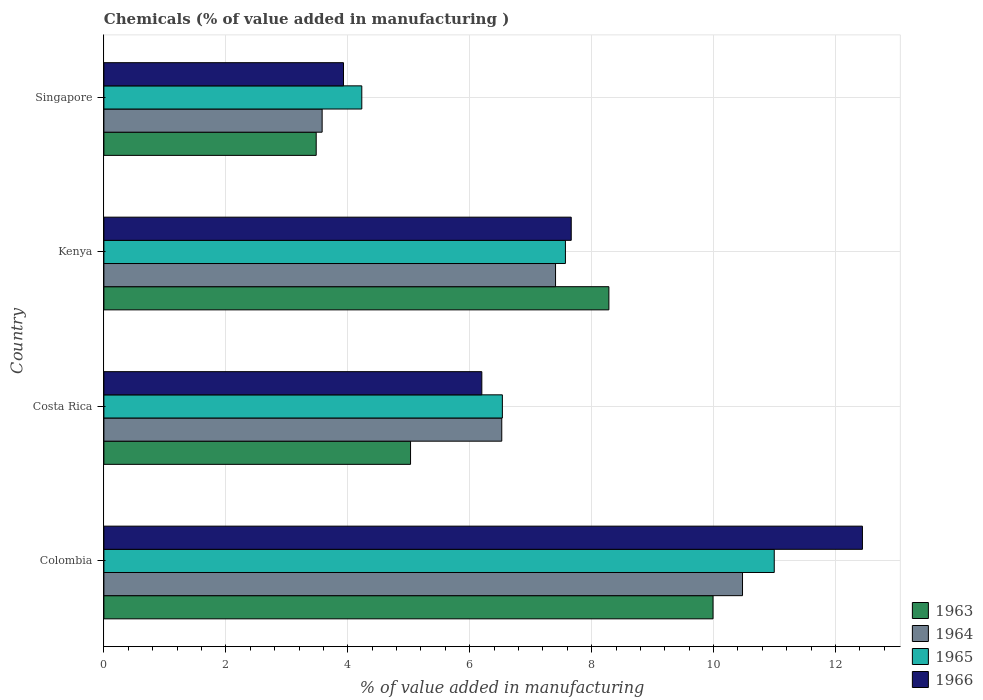Are the number of bars per tick equal to the number of legend labels?
Ensure brevity in your answer.  Yes. What is the label of the 1st group of bars from the top?
Keep it short and to the point. Singapore. In how many cases, is the number of bars for a given country not equal to the number of legend labels?
Keep it short and to the point. 0. What is the value added in manufacturing chemicals in 1963 in Costa Rica?
Make the answer very short. 5.03. Across all countries, what is the maximum value added in manufacturing chemicals in 1964?
Offer a very short reply. 10.47. Across all countries, what is the minimum value added in manufacturing chemicals in 1964?
Give a very brief answer. 3.58. In which country was the value added in manufacturing chemicals in 1964 minimum?
Make the answer very short. Singapore. What is the total value added in manufacturing chemicals in 1966 in the graph?
Give a very brief answer. 30.23. What is the difference between the value added in manufacturing chemicals in 1964 in Colombia and that in Costa Rica?
Give a very brief answer. 3.95. What is the difference between the value added in manufacturing chemicals in 1964 in Costa Rica and the value added in manufacturing chemicals in 1965 in Singapore?
Provide a succinct answer. 2.3. What is the average value added in manufacturing chemicals in 1963 per country?
Offer a very short reply. 6.7. What is the difference between the value added in manufacturing chemicals in 1965 and value added in manufacturing chemicals in 1963 in Colombia?
Keep it short and to the point. 1. What is the ratio of the value added in manufacturing chemicals in 1963 in Colombia to that in Costa Rica?
Your response must be concise. 1.99. Is the difference between the value added in manufacturing chemicals in 1965 in Kenya and Singapore greater than the difference between the value added in manufacturing chemicals in 1963 in Kenya and Singapore?
Keep it short and to the point. No. What is the difference between the highest and the second highest value added in manufacturing chemicals in 1965?
Offer a very short reply. 3.43. What is the difference between the highest and the lowest value added in manufacturing chemicals in 1963?
Ensure brevity in your answer.  6.51. In how many countries, is the value added in manufacturing chemicals in 1964 greater than the average value added in manufacturing chemicals in 1964 taken over all countries?
Your answer should be compact. 2. Is it the case that in every country, the sum of the value added in manufacturing chemicals in 1963 and value added in manufacturing chemicals in 1964 is greater than the sum of value added in manufacturing chemicals in 1965 and value added in manufacturing chemicals in 1966?
Provide a succinct answer. No. What does the 2nd bar from the top in Colombia represents?
Offer a very short reply. 1965. What does the 4th bar from the bottom in Kenya represents?
Your answer should be compact. 1966. Is it the case that in every country, the sum of the value added in manufacturing chemicals in 1965 and value added in manufacturing chemicals in 1964 is greater than the value added in manufacturing chemicals in 1963?
Keep it short and to the point. Yes. How many bars are there?
Provide a succinct answer. 16. Are all the bars in the graph horizontal?
Provide a succinct answer. Yes. How many countries are there in the graph?
Provide a succinct answer. 4. Are the values on the major ticks of X-axis written in scientific E-notation?
Offer a very short reply. No. Does the graph contain grids?
Your answer should be compact. Yes. How many legend labels are there?
Your answer should be very brief. 4. What is the title of the graph?
Make the answer very short. Chemicals (% of value added in manufacturing ). What is the label or title of the X-axis?
Keep it short and to the point. % of value added in manufacturing. What is the % of value added in manufacturing in 1963 in Colombia?
Offer a terse response. 9.99. What is the % of value added in manufacturing in 1964 in Colombia?
Ensure brevity in your answer.  10.47. What is the % of value added in manufacturing in 1965 in Colombia?
Provide a succinct answer. 10.99. What is the % of value added in manufacturing of 1966 in Colombia?
Your response must be concise. 12.44. What is the % of value added in manufacturing of 1963 in Costa Rica?
Your response must be concise. 5.03. What is the % of value added in manufacturing of 1964 in Costa Rica?
Keep it short and to the point. 6.53. What is the % of value added in manufacturing of 1965 in Costa Rica?
Ensure brevity in your answer.  6.54. What is the % of value added in manufacturing in 1966 in Costa Rica?
Ensure brevity in your answer.  6.2. What is the % of value added in manufacturing in 1963 in Kenya?
Offer a terse response. 8.28. What is the % of value added in manufacturing in 1964 in Kenya?
Offer a terse response. 7.41. What is the % of value added in manufacturing of 1965 in Kenya?
Offer a very short reply. 7.57. What is the % of value added in manufacturing in 1966 in Kenya?
Offer a very short reply. 7.67. What is the % of value added in manufacturing of 1963 in Singapore?
Your response must be concise. 3.48. What is the % of value added in manufacturing of 1964 in Singapore?
Offer a terse response. 3.58. What is the % of value added in manufacturing of 1965 in Singapore?
Make the answer very short. 4.23. What is the % of value added in manufacturing in 1966 in Singapore?
Provide a succinct answer. 3.93. Across all countries, what is the maximum % of value added in manufacturing in 1963?
Provide a succinct answer. 9.99. Across all countries, what is the maximum % of value added in manufacturing in 1964?
Give a very brief answer. 10.47. Across all countries, what is the maximum % of value added in manufacturing in 1965?
Give a very brief answer. 10.99. Across all countries, what is the maximum % of value added in manufacturing in 1966?
Keep it short and to the point. 12.44. Across all countries, what is the minimum % of value added in manufacturing in 1963?
Offer a very short reply. 3.48. Across all countries, what is the minimum % of value added in manufacturing in 1964?
Provide a succinct answer. 3.58. Across all countries, what is the minimum % of value added in manufacturing of 1965?
Provide a succinct answer. 4.23. Across all countries, what is the minimum % of value added in manufacturing of 1966?
Your answer should be very brief. 3.93. What is the total % of value added in manufacturing of 1963 in the graph?
Make the answer very short. 26.79. What is the total % of value added in manufacturing in 1964 in the graph?
Your answer should be very brief. 27.99. What is the total % of value added in manufacturing in 1965 in the graph?
Offer a terse response. 29.33. What is the total % of value added in manufacturing of 1966 in the graph?
Ensure brevity in your answer.  30.23. What is the difference between the % of value added in manufacturing in 1963 in Colombia and that in Costa Rica?
Offer a terse response. 4.96. What is the difference between the % of value added in manufacturing in 1964 in Colombia and that in Costa Rica?
Your answer should be very brief. 3.95. What is the difference between the % of value added in manufacturing in 1965 in Colombia and that in Costa Rica?
Keep it short and to the point. 4.46. What is the difference between the % of value added in manufacturing in 1966 in Colombia and that in Costa Rica?
Keep it short and to the point. 6.24. What is the difference between the % of value added in manufacturing in 1963 in Colombia and that in Kenya?
Your answer should be very brief. 1.71. What is the difference between the % of value added in manufacturing of 1964 in Colombia and that in Kenya?
Keep it short and to the point. 3.07. What is the difference between the % of value added in manufacturing in 1965 in Colombia and that in Kenya?
Offer a very short reply. 3.43. What is the difference between the % of value added in manufacturing in 1966 in Colombia and that in Kenya?
Offer a terse response. 4.78. What is the difference between the % of value added in manufacturing in 1963 in Colombia and that in Singapore?
Your answer should be very brief. 6.51. What is the difference between the % of value added in manufacturing of 1964 in Colombia and that in Singapore?
Provide a short and direct response. 6.89. What is the difference between the % of value added in manufacturing of 1965 in Colombia and that in Singapore?
Provide a succinct answer. 6.76. What is the difference between the % of value added in manufacturing of 1966 in Colombia and that in Singapore?
Offer a very short reply. 8.51. What is the difference between the % of value added in manufacturing of 1963 in Costa Rica and that in Kenya?
Ensure brevity in your answer.  -3.25. What is the difference between the % of value added in manufacturing of 1964 in Costa Rica and that in Kenya?
Your answer should be compact. -0.88. What is the difference between the % of value added in manufacturing in 1965 in Costa Rica and that in Kenya?
Ensure brevity in your answer.  -1.03. What is the difference between the % of value added in manufacturing of 1966 in Costa Rica and that in Kenya?
Provide a succinct answer. -1.47. What is the difference between the % of value added in manufacturing of 1963 in Costa Rica and that in Singapore?
Provide a succinct answer. 1.55. What is the difference between the % of value added in manufacturing of 1964 in Costa Rica and that in Singapore?
Your answer should be very brief. 2.95. What is the difference between the % of value added in manufacturing of 1965 in Costa Rica and that in Singapore?
Your answer should be very brief. 2.31. What is the difference between the % of value added in manufacturing in 1966 in Costa Rica and that in Singapore?
Provide a short and direct response. 2.27. What is the difference between the % of value added in manufacturing in 1963 in Kenya and that in Singapore?
Ensure brevity in your answer.  4.8. What is the difference between the % of value added in manufacturing of 1964 in Kenya and that in Singapore?
Make the answer very short. 3.83. What is the difference between the % of value added in manufacturing of 1965 in Kenya and that in Singapore?
Give a very brief answer. 3.34. What is the difference between the % of value added in manufacturing of 1966 in Kenya and that in Singapore?
Your response must be concise. 3.74. What is the difference between the % of value added in manufacturing of 1963 in Colombia and the % of value added in manufacturing of 1964 in Costa Rica?
Your answer should be compact. 3.47. What is the difference between the % of value added in manufacturing of 1963 in Colombia and the % of value added in manufacturing of 1965 in Costa Rica?
Your response must be concise. 3.46. What is the difference between the % of value added in manufacturing in 1963 in Colombia and the % of value added in manufacturing in 1966 in Costa Rica?
Offer a terse response. 3.79. What is the difference between the % of value added in manufacturing of 1964 in Colombia and the % of value added in manufacturing of 1965 in Costa Rica?
Keep it short and to the point. 3.94. What is the difference between the % of value added in manufacturing in 1964 in Colombia and the % of value added in manufacturing in 1966 in Costa Rica?
Offer a terse response. 4.28. What is the difference between the % of value added in manufacturing of 1965 in Colombia and the % of value added in manufacturing of 1966 in Costa Rica?
Keep it short and to the point. 4.8. What is the difference between the % of value added in manufacturing in 1963 in Colombia and the % of value added in manufacturing in 1964 in Kenya?
Offer a very short reply. 2.58. What is the difference between the % of value added in manufacturing in 1963 in Colombia and the % of value added in manufacturing in 1965 in Kenya?
Offer a very short reply. 2.42. What is the difference between the % of value added in manufacturing of 1963 in Colombia and the % of value added in manufacturing of 1966 in Kenya?
Ensure brevity in your answer.  2.33. What is the difference between the % of value added in manufacturing in 1964 in Colombia and the % of value added in manufacturing in 1965 in Kenya?
Provide a succinct answer. 2.9. What is the difference between the % of value added in manufacturing of 1964 in Colombia and the % of value added in manufacturing of 1966 in Kenya?
Your response must be concise. 2.81. What is the difference between the % of value added in manufacturing of 1965 in Colombia and the % of value added in manufacturing of 1966 in Kenya?
Your answer should be compact. 3.33. What is the difference between the % of value added in manufacturing of 1963 in Colombia and the % of value added in manufacturing of 1964 in Singapore?
Keep it short and to the point. 6.41. What is the difference between the % of value added in manufacturing of 1963 in Colombia and the % of value added in manufacturing of 1965 in Singapore?
Provide a short and direct response. 5.76. What is the difference between the % of value added in manufacturing in 1963 in Colombia and the % of value added in manufacturing in 1966 in Singapore?
Keep it short and to the point. 6.06. What is the difference between the % of value added in manufacturing in 1964 in Colombia and the % of value added in manufacturing in 1965 in Singapore?
Your response must be concise. 6.24. What is the difference between the % of value added in manufacturing in 1964 in Colombia and the % of value added in manufacturing in 1966 in Singapore?
Ensure brevity in your answer.  6.54. What is the difference between the % of value added in manufacturing in 1965 in Colombia and the % of value added in manufacturing in 1966 in Singapore?
Your answer should be compact. 7.07. What is the difference between the % of value added in manufacturing of 1963 in Costa Rica and the % of value added in manufacturing of 1964 in Kenya?
Ensure brevity in your answer.  -2.38. What is the difference between the % of value added in manufacturing in 1963 in Costa Rica and the % of value added in manufacturing in 1965 in Kenya?
Ensure brevity in your answer.  -2.54. What is the difference between the % of value added in manufacturing in 1963 in Costa Rica and the % of value added in manufacturing in 1966 in Kenya?
Your answer should be very brief. -2.64. What is the difference between the % of value added in manufacturing in 1964 in Costa Rica and the % of value added in manufacturing in 1965 in Kenya?
Provide a short and direct response. -1.04. What is the difference between the % of value added in manufacturing of 1964 in Costa Rica and the % of value added in manufacturing of 1966 in Kenya?
Give a very brief answer. -1.14. What is the difference between the % of value added in manufacturing in 1965 in Costa Rica and the % of value added in manufacturing in 1966 in Kenya?
Give a very brief answer. -1.13. What is the difference between the % of value added in manufacturing of 1963 in Costa Rica and the % of value added in manufacturing of 1964 in Singapore?
Your answer should be compact. 1.45. What is the difference between the % of value added in manufacturing of 1963 in Costa Rica and the % of value added in manufacturing of 1965 in Singapore?
Offer a terse response. 0.8. What is the difference between the % of value added in manufacturing of 1963 in Costa Rica and the % of value added in manufacturing of 1966 in Singapore?
Keep it short and to the point. 1.1. What is the difference between the % of value added in manufacturing in 1964 in Costa Rica and the % of value added in manufacturing in 1965 in Singapore?
Provide a short and direct response. 2.3. What is the difference between the % of value added in manufacturing in 1964 in Costa Rica and the % of value added in manufacturing in 1966 in Singapore?
Provide a short and direct response. 2.6. What is the difference between the % of value added in manufacturing in 1965 in Costa Rica and the % of value added in manufacturing in 1966 in Singapore?
Your answer should be compact. 2.61. What is the difference between the % of value added in manufacturing of 1963 in Kenya and the % of value added in manufacturing of 1964 in Singapore?
Keep it short and to the point. 4.7. What is the difference between the % of value added in manufacturing in 1963 in Kenya and the % of value added in manufacturing in 1965 in Singapore?
Provide a succinct answer. 4.05. What is the difference between the % of value added in manufacturing of 1963 in Kenya and the % of value added in manufacturing of 1966 in Singapore?
Your answer should be compact. 4.35. What is the difference between the % of value added in manufacturing of 1964 in Kenya and the % of value added in manufacturing of 1965 in Singapore?
Make the answer very short. 3.18. What is the difference between the % of value added in manufacturing in 1964 in Kenya and the % of value added in manufacturing in 1966 in Singapore?
Ensure brevity in your answer.  3.48. What is the difference between the % of value added in manufacturing of 1965 in Kenya and the % of value added in manufacturing of 1966 in Singapore?
Your answer should be compact. 3.64. What is the average % of value added in manufacturing of 1963 per country?
Give a very brief answer. 6.7. What is the average % of value added in manufacturing of 1964 per country?
Provide a short and direct response. 7. What is the average % of value added in manufacturing of 1965 per country?
Provide a short and direct response. 7.33. What is the average % of value added in manufacturing in 1966 per country?
Your answer should be very brief. 7.56. What is the difference between the % of value added in manufacturing of 1963 and % of value added in manufacturing of 1964 in Colombia?
Give a very brief answer. -0.48. What is the difference between the % of value added in manufacturing of 1963 and % of value added in manufacturing of 1965 in Colombia?
Make the answer very short. -1. What is the difference between the % of value added in manufacturing in 1963 and % of value added in manufacturing in 1966 in Colombia?
Offer a terse response. -2.45. What is the difference between the % of value added in manufacturing of 1964 and % of value added in manufacturing of 1965 in Colombia?
Offer a very short reply. -0.52. What is the difference between the % of value added in manufacturing in 1964 and % of value added in manufacturing in 1966 in Colombia?
Offer a very short reply. -1.97. What is the difference between the % of value added in manufacturing in 1965 and % of value added in manufacturing in 1966 in Colombia?
Make the answer very short. -1.45. What is the difference between the % of value added in manufacturing of 1963 and % of value added in manufacturing of 1964 in Costa Rica?
Offer a terse response. -1.5. What is the difference between the % of value added in manufacturing of 1963 and % of value added in manufacturing of 1965 in Costa Rica?
Provide a short and direct response. -1.51. What is the difference between the % of value added in manufacturing of 1963 and % of value added in manufacturing of 1966 in Costa Rica?
Make the answer very short. -1.17. What is the difference between the % of value added in manufacturing of 1964 and % of value added in manufacturing of 1965 in Costa Rica?
Ensure brevity in your answer.  -0.01. What is the difference between the % of value added in manufacturing in 1964 and % of value added in manufacturing in 1966 in Costa Rica?
Provide a succinct answer. 0.33. What is the difference between the % of value added in manufacturing of 1965 and % of value added in manufacturing of 1966 in Costa Rica?
Your answer should be compact. 0.34. What is the difference between the % of value added in manufacturing of 1963 and % of value added in manufacturing of 1964 in Kenya?
Your answer should be compact. 0.87. What is the difference between the % of value added in manufacturing of 1963 and % of value added in manufacturing of 1965 in Kenya?
Offer a very short reply. 0.71. What is the difference between the % of value added in manufacturing in 1963 and % of value added in manufacturing in 1966 in Kenya?
Your answer should be very brief. 0.62. What is the difference between the % of value added in manufacturing of 1964 and % of value added in manufacturing of 1965 in Kenya?
Your answer should be very brief. -0.16. What is the difference between the % of value added in manufacturing of 1964 and % of value added in manufacturing of 1966 in Kenya?
Your answer should be very brief. -0.26. What is the difference between the % of value added in manufacturing of 1965 and % of value added in manufacturing of 1966 in Kenya?
Offer a very short reply. -0.1. What is the difference between the % of value added in manufacturing of 1963 and % of value added in manufacturing of 1964 in Singapore?
Provide a succinct answer. -0.1. What is the difference between the % of value added in manufacturing in 1963 and % of value added in manufacturing in 1965 in Singapore?
Provide a succinct answer. -0.75. What is the difference between the % of value added in manufacturing in 1963 and % of value added in manufacturing in 1966 in Singapore?
Ensure brevity in your answer.  -0.45. What is the difference between the % of value added in manufacturing of 1964 and % of value added in manufacturing of 1965 in Singapore?
Offer a terse response. -0.65. What is the difference between the % of value added in manufacturing of 1964 and % of value added in manufacturing of 1966 in Singapore?
Give a very brief answer. -0.35. What is the difference between the % of value added in manufacturing of 1965 and % of value added in manufacturing of 1966 in Singapore?
Offer a terse response. 0.3. What is the ratio of the % of value added in manufacturing of 1963 in Colombia to that in Costa Rica?
Provide a short and direct response. 1.99. What is the ratio of the % of value added in manufacturing of 1964 in Colombia to that in Costa Rica?
Offer a terse response. 1.61. What is the ratio of the % of value added in manufacturing in 1965 in Colombia to that in Costa Rica?
Provide a succinct answer. 1.68. What is the ratio of the % of value added in manufacturing of 1966 in Colombia to that in Costa Rica?
Provide a succinct answer. 2.01. What is the ratio of the % of value added in manufacturing of 1963 in Colombia to that in Kenya?
Provide a short and direct response. 1.21. What is the ratio of the % of value added in manufacturing of 1964 in Colombia to that in Kenya?
Your response must be concise. 1.41. What is the ratio of the % of value added in manufacturing in 1965 in Colombia to that in Kenya?
Keep it short and to the point. 1.45. What is the ratio of the % of value added in manufacturing in 1966 in Colombia to that in Kenya?
Keep it short and to the point. 1.62. What is the ratio of the % of value added in manufacturing of 1963 in Colombia to that in Singapore?
Provide a succinct answer. 2.87. What is the ratio of the % of value added in manufacturing in 1964 in Colombia to that in Singapore?
Your answer should be compact. 2.93. What is the ratio of the % of value added in manufacturing of 1965 in Colombia to that in Singapore?
Keep it short and to the point. 2.6. What is the ratio of the % of value added in manufacturing of 1966 in Colombia to that in Singapore?
Provide a succinct answer. 3.17. What is the ratio of the % of value added in manufacturing in 1963 in Costa Rica to that in Kenya?
Ensure brevity in your answer.  0.61. What is the ratio of the % of value added in manufacturing of 1964 in Costa Rica to that in Kenya?
Make the answer very short. 0.88. What is the ratio of the % of value added in manufacturing in 1965 in Costa Rica to that in Kenya?
Ensure brevity in your answer.  0.86. What is the ratio of the % of value added in manufacturing of 1966 in Costa Rica to that in Kenya?
Make the answer very short. 0.81. What is the ratio of the % of value added in manufacturing in 1963 in Costa Rica to that in Singapore?
Ensure brevity in your answer.  1.44. What is the ratio of the % of value added in manufacturing of 1964 in Costa Rica to that in Singapore?
Make the answer very short. 1.82. What is the ratio of the % of value added in manufacturing of 1965 in Costa Rica to that in Singapore?
Ensure brevity in your answer.  1.55. What is the ratio of the % of value added in manufacturing in 1966 in Costa Rica to that in Singapore?
Your answer should be compact. 1.58. What is the ratio of the % of value added in manufacturing in 1963 in Kenya to that in Singapore?
Your response must be concise. 2.38. What is the ratio of the % of value added in manufacturing of 1964 in Kenya to that in Singapore?
Your response must be concise. 2.07. What is the ratio of the % of value added in manufacturing of 1965 in Kenya to that in Singapore?
Ensure brevity in your answer.  1.79. What is the ratio of the % of value added in manufacturing of 1966 in Kenya to that in Singapore?
Make the answer very short. 1.95. What is the difference between the highest and the second highest % of value added in manufacturing of 1963?
Give a very brief answer. 1.71. What is the difference between the highest and the second highest % of value added in manufacturing in 1964?
Your response must be concise. 3.07. What is the difference between the highest and the second highest % of value added in manufacturing in 1965?
Your answer should be compact. 3.43. What is the difference between the highest and the second highest % of value added in manufacturing in 1966?
Provide a succinct answer. 4.78. What is the difference between the highest and the lowest % of value added in manufacturing in 1963?
Make the answer very short. 6.51. What is the difference between the highest and the lowest % of value added in manufacturing in 1964?
Your answer should be compact. 6.89. What is the difference between the highest and the lowest % of value added in manufacturing in 1965?
Offer a very short reply. 6.76. What is the difference between the highest and the lowest % of value added in manufacturing in 1966?
Offer a terse response. 8.51. 